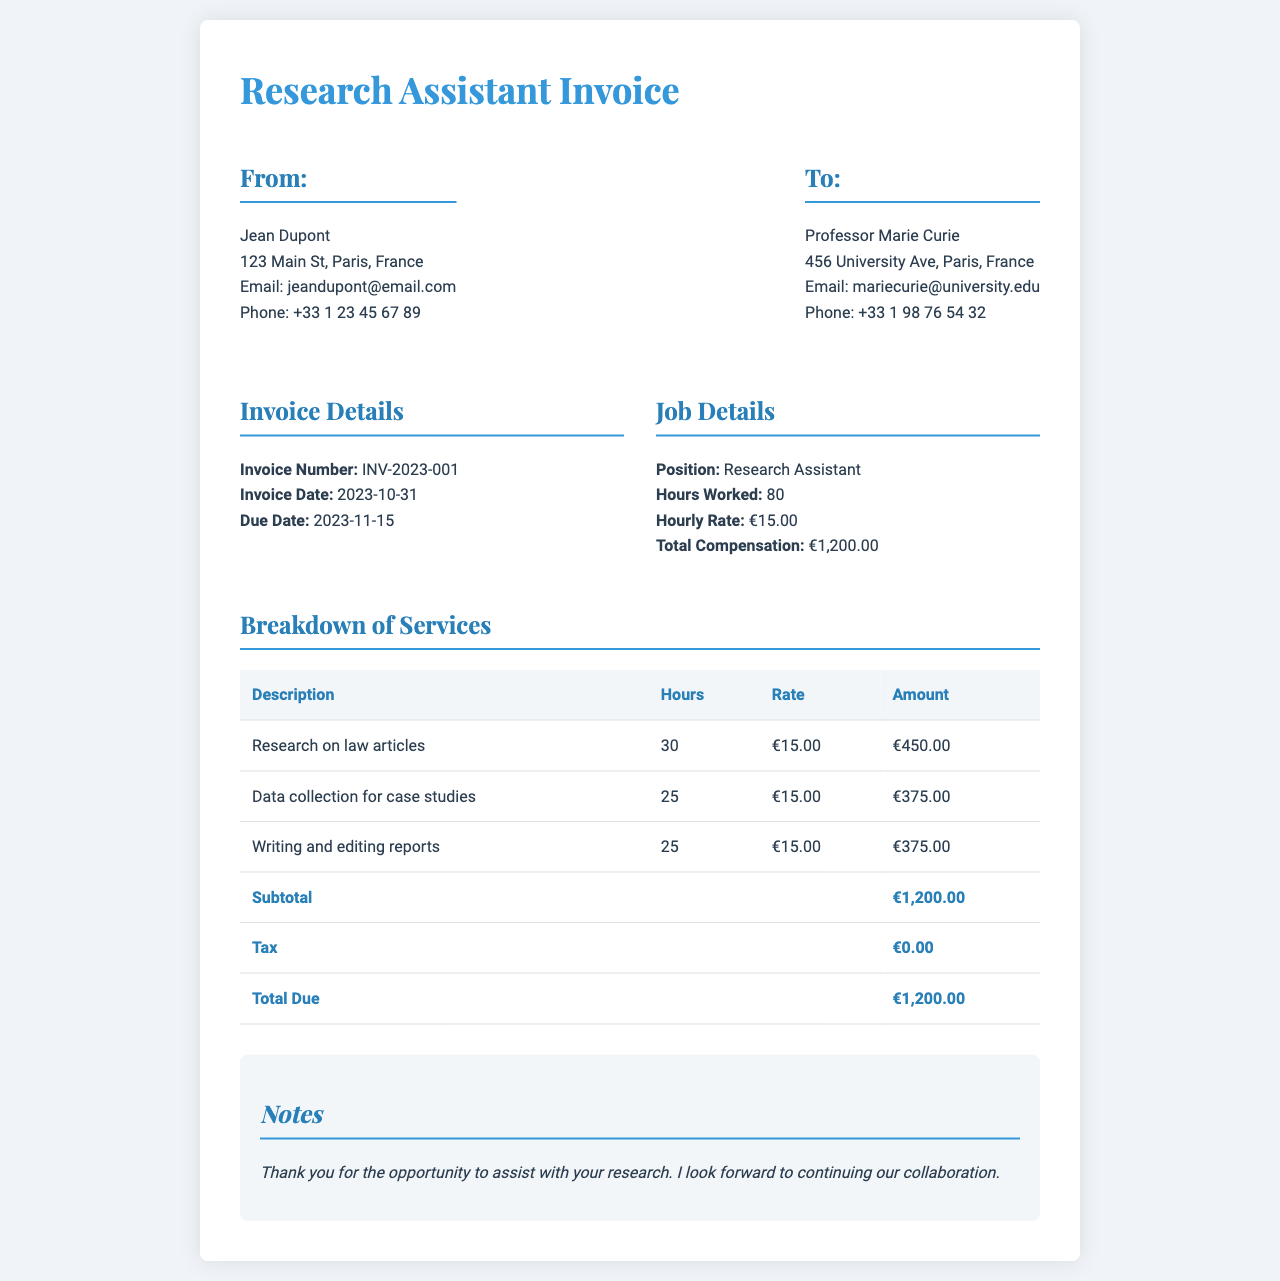What is the invoice number? The invoice number is listed in the invoice details section as INV-2023-001.
Answer: INV-2023-001 Who is the recipient of the invoice? The recipient, listed in the "To" section, is Professor Marie Curie.
Answer: Professor Marie Curie What is the hourly rate for the research assistant? The hourly rate is specified in the job details section as €15.00.
Answer: €15.00 How many hours did the research assistant work? The hours worked are indicated in the job details section as 80 hours.
Answer: 80 What is the total compensation for the month? The total compensation is provided in the job details section as €1,200.00.
Answer: €1,200.00 What services are included in the breakdown? The services provided include "Research on law articles," "Data collection for case studies," and "Writing and editing reports."
Answer: Research on law articles, Data collection for case studies, Writing and editing reports What is the subtotal before any tax? The subtotal is specifically stated in the breakdown of services as €1,200.00.
Answer: €1,200.00 What is the due date for this invoice? The due date is mentioned in the invoice details section as 2023-11-15.
Answer: 2023-11-15 What notes are included in the invoice? The notes express gratitude for the opportunity to assist with research and mention looking forward to continuing collaboration.
Answer: Thank you for the opportunity to assist with your research. I look forward to continuing our collaboration 